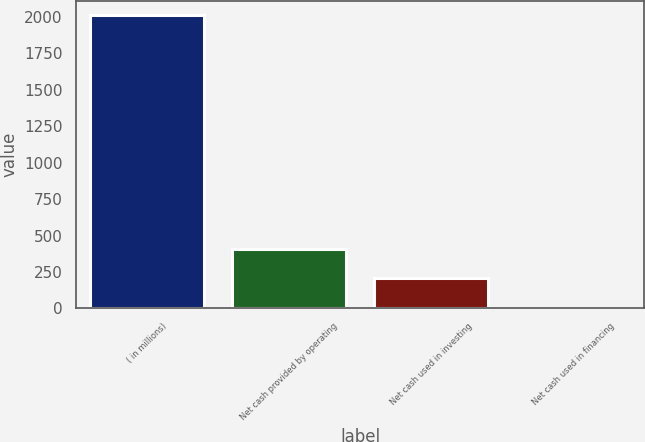Convert chart to OTSL. <chart><loc_0><loc_0><loc_500><loc_500><bar_chart><fcel>( in millions)<fcel>Net cash provided by operating<fcel>Net cash used in investing<fcel>Net cash used in financing<nl><fcel>2013<fcel>406.68<fcel>205.89<fcel>5.1<nl></chart> 